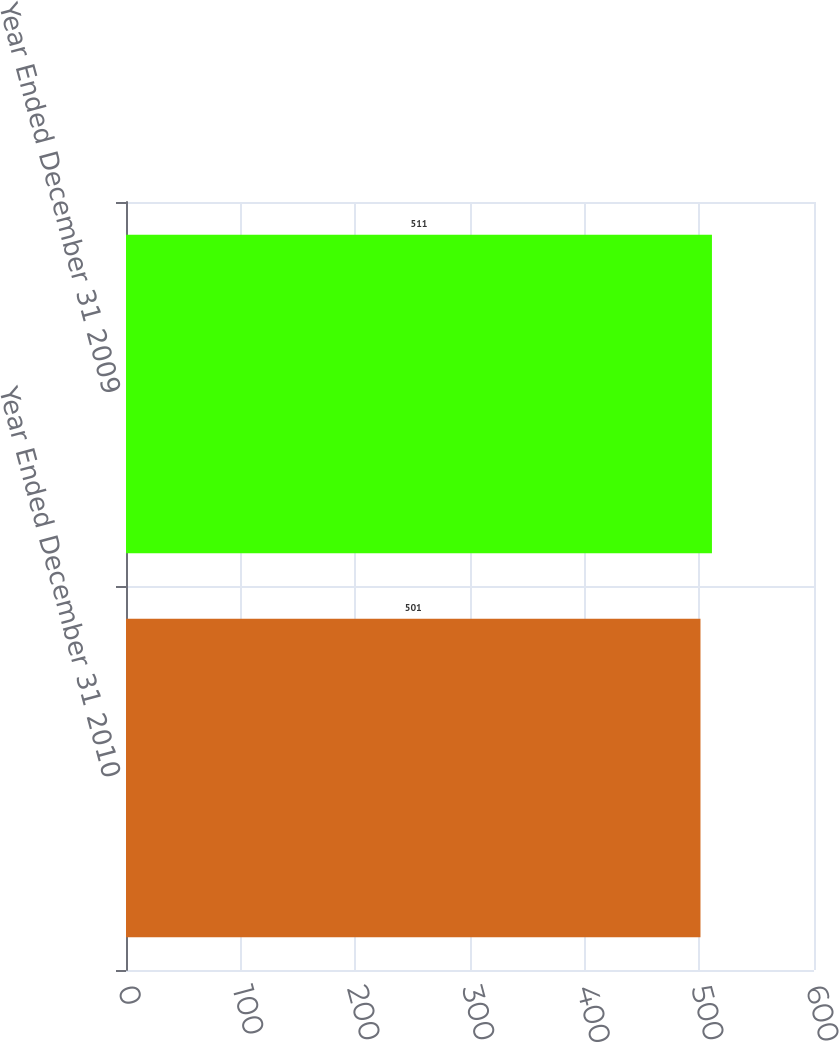<chart> <loc_0><loc_0><loc_500><loc_500><bar_chart><fcel>Year Ended December 31 2010<fcel>Year Ended December 31 2009<nl><fcel>501<fcel>511<nl></chart> 